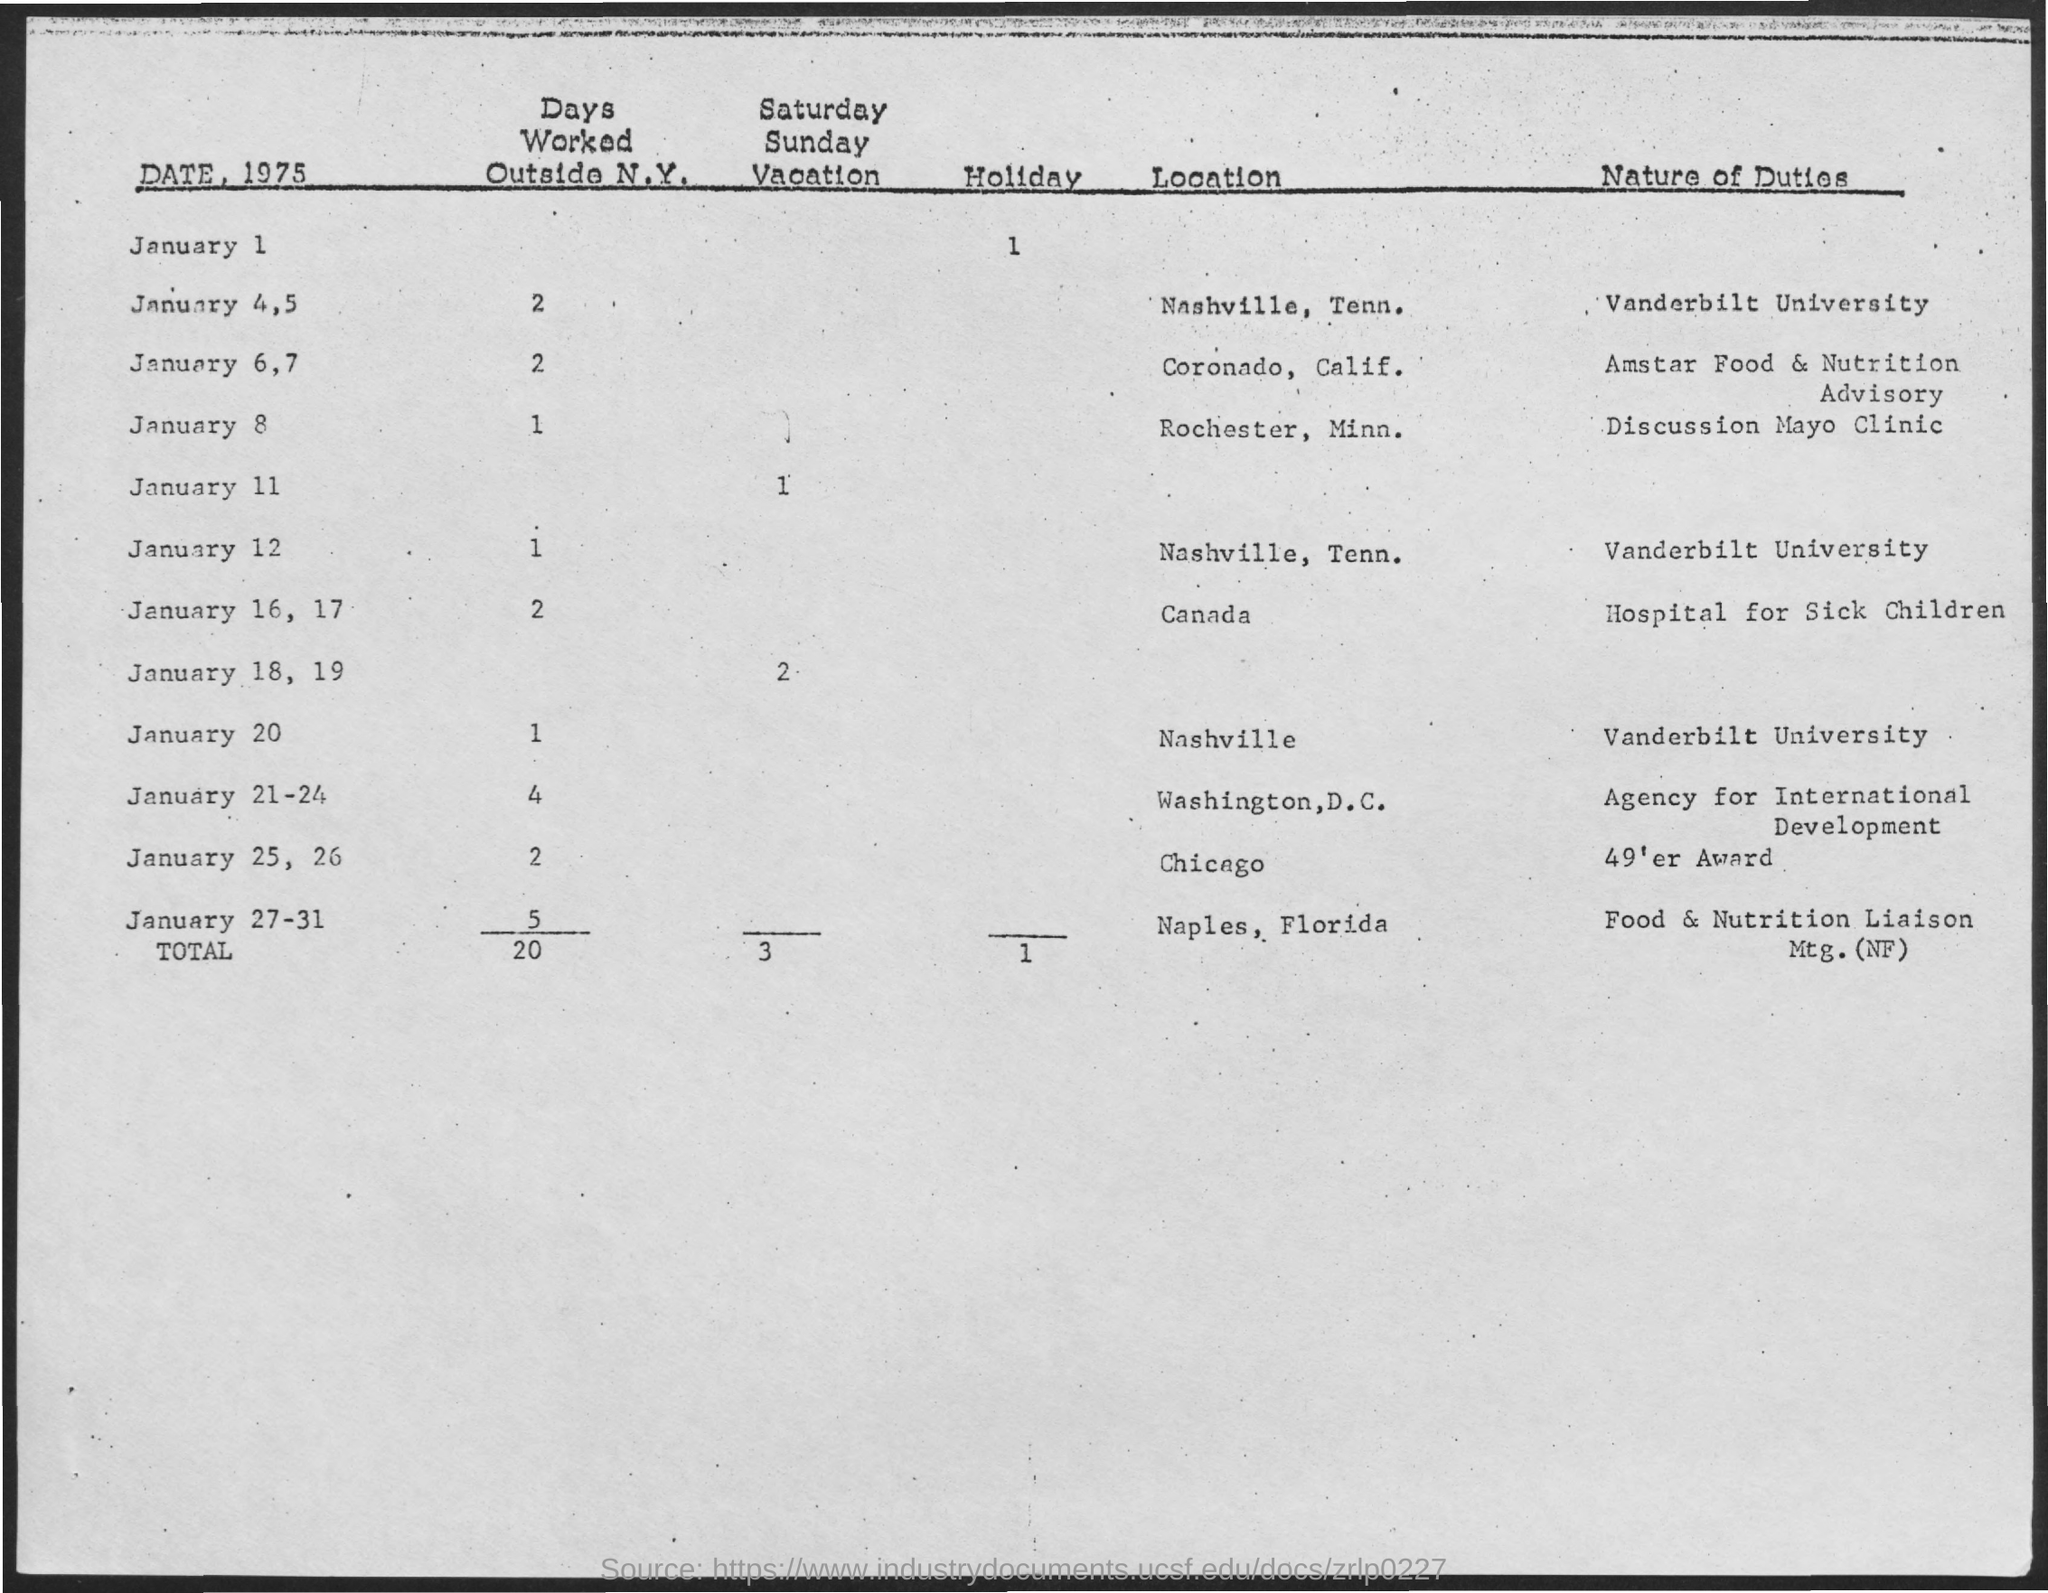Point out several critical features in this image. In total, the individual has worked 20 days outside of New York. What is the nature of duty on January 12? This question remains a point of contention, with some sources citing duty as a requirement for all individuals, while others argue that its meaning and application are subject to interpretation and individual circumstances. There are a total of three Saturday-Sunday vacations. The nature of duty on January 20, 1986, at Vanderbilt University remains a topic of debate. The total number of holidays is 1.. 